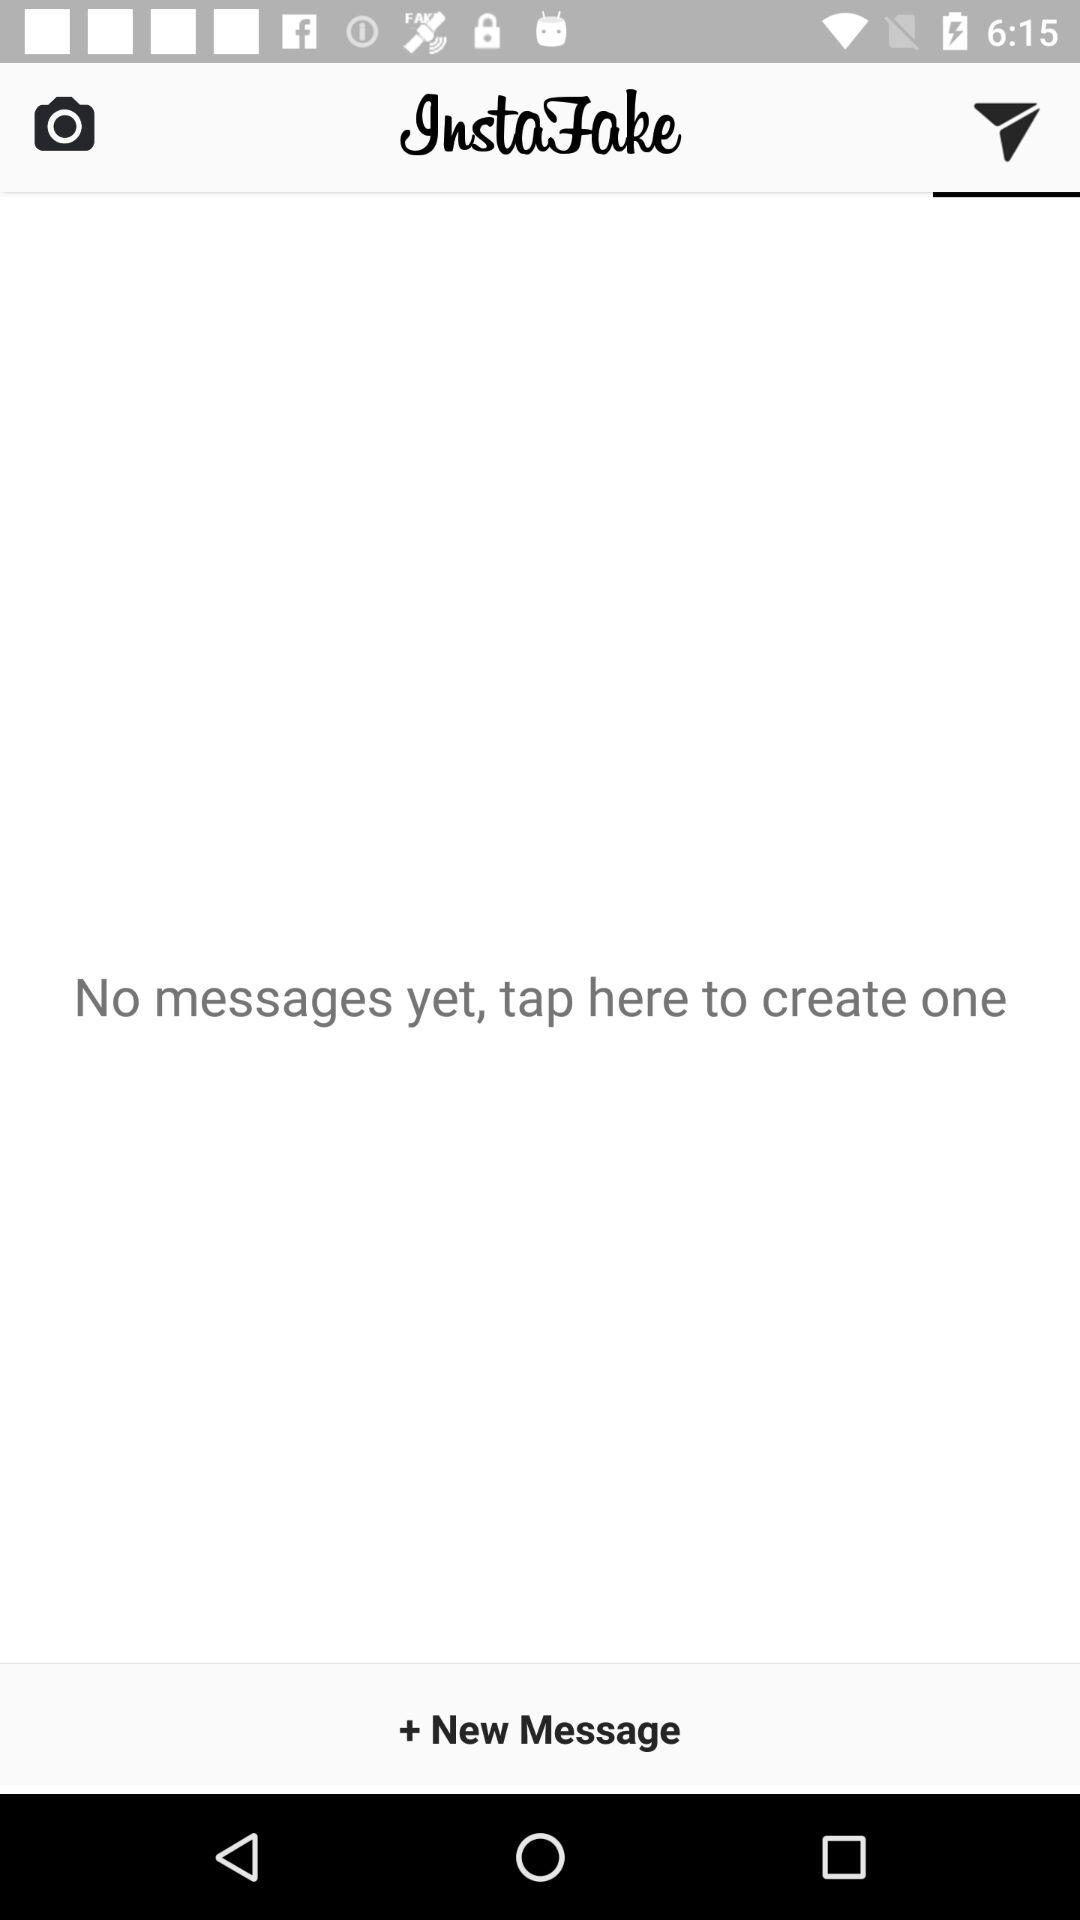What is the application name? The application name is "InstaFake". 